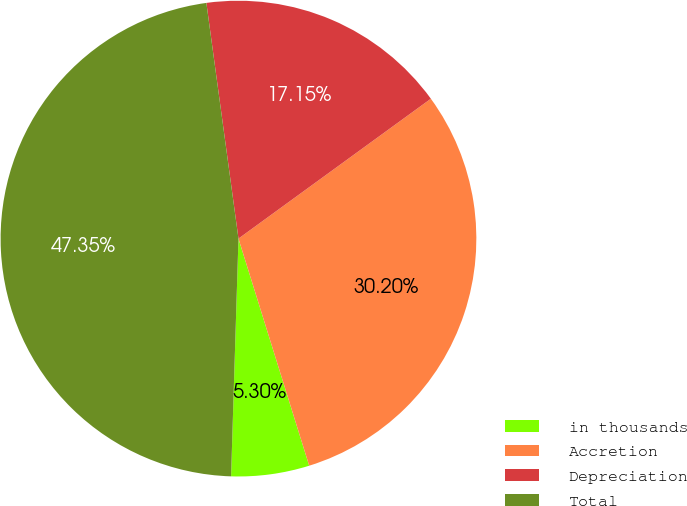Convert chart. <chart><loc_0><loc_0><loc_500><loc_500><pie_chart><fcel>in thousands<fcel>Accretion<fcel>Depreciation<fcel>Total<nl><fcel>5.3%<fcel>30.2%<fcel>17.15%<fcel>47.35%<nl></chart> 